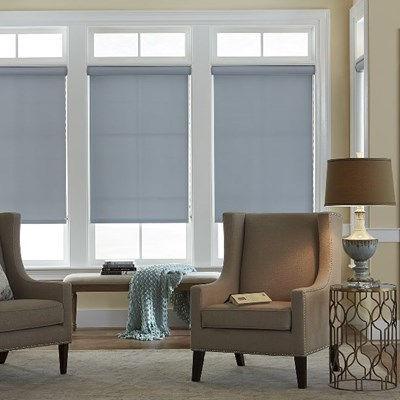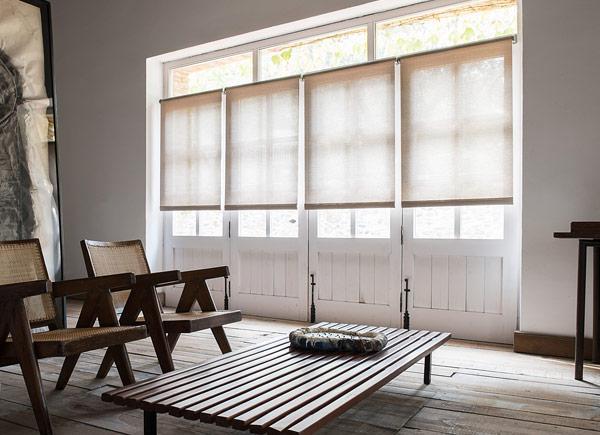The first image is the image on the left, the second image is the image on the right. For the images shown, is this caption "There are three window shades in one image, and four window shades in the other image." true? Answer yes or no. Yes. The first image is the image on the left, the second image is the image on the right. Examine the images to the left and right. Is the description "In the image to the left, you can see the lamp." accurate? Answer yes or no. Yes. 